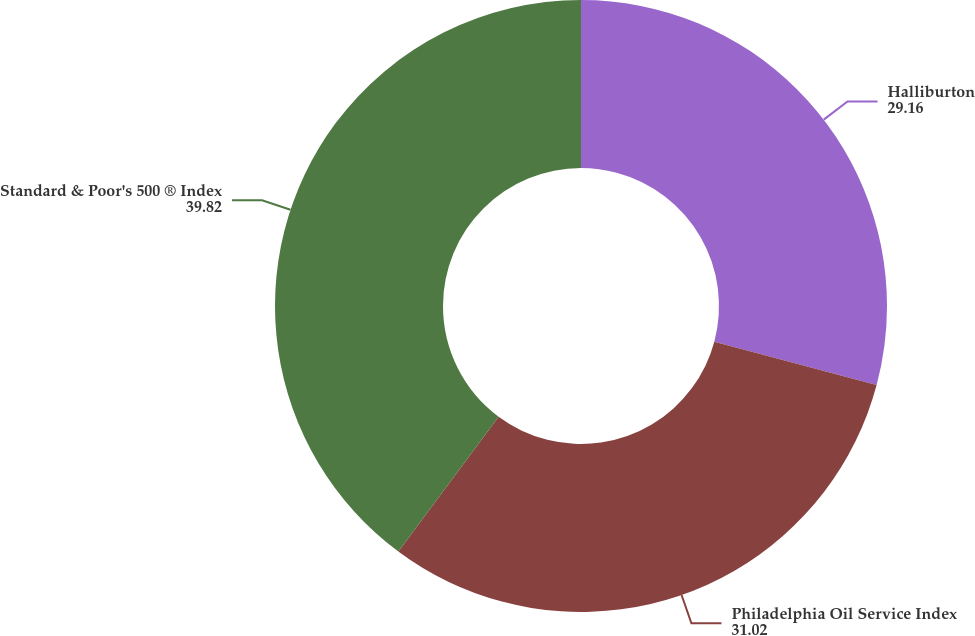Convert chart to OTSL. <chart><loc_0><loc_0><loc_500><loc_500><pie_chart><fcel>Halliburton<fcel>Philadelphia Oil Service Index<fcel>Standard & Poor's 500 ® Index<nl><fcel>29.16%<fcel>31.02%<fcel>39.82%<nl></chart> 